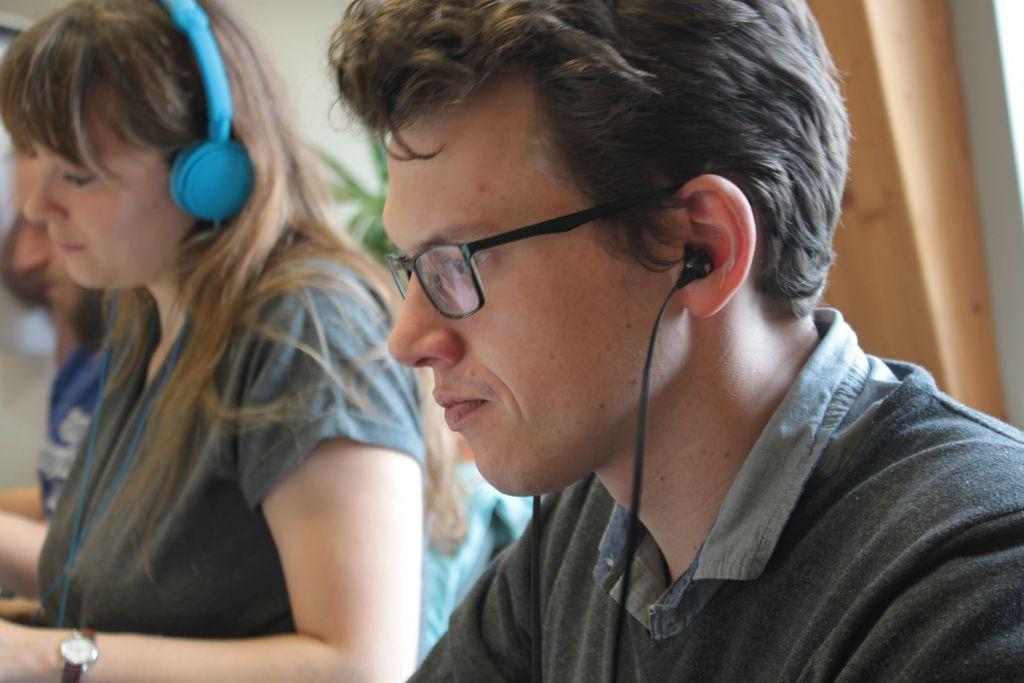Please provide a concise description of this image. Here we can see a man and woman. In the background there is a wall,plant,a person and an object. 